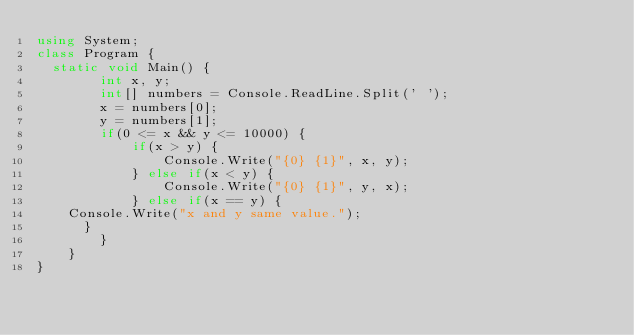<code> <loc_0><loc_0><loc_500><loc_500><_C#_>using System;
class Program {
	static void Main() {
        int x, y;
        int[] numbers = Console.ReadLine.Split(' ');
        x = numbers[0];
        y = numbers[1];
        if(0 <= x && y <= 10000) {
            if(x > y) {
                Console.Write("{0} {1}", x, y);
            } else if(x < y) {
                Console.Write("{0} {1}", y, x);
            } else if(x == y) {
		Console.Write("x and y same value.");
	    }
        }
    }
}</code> 